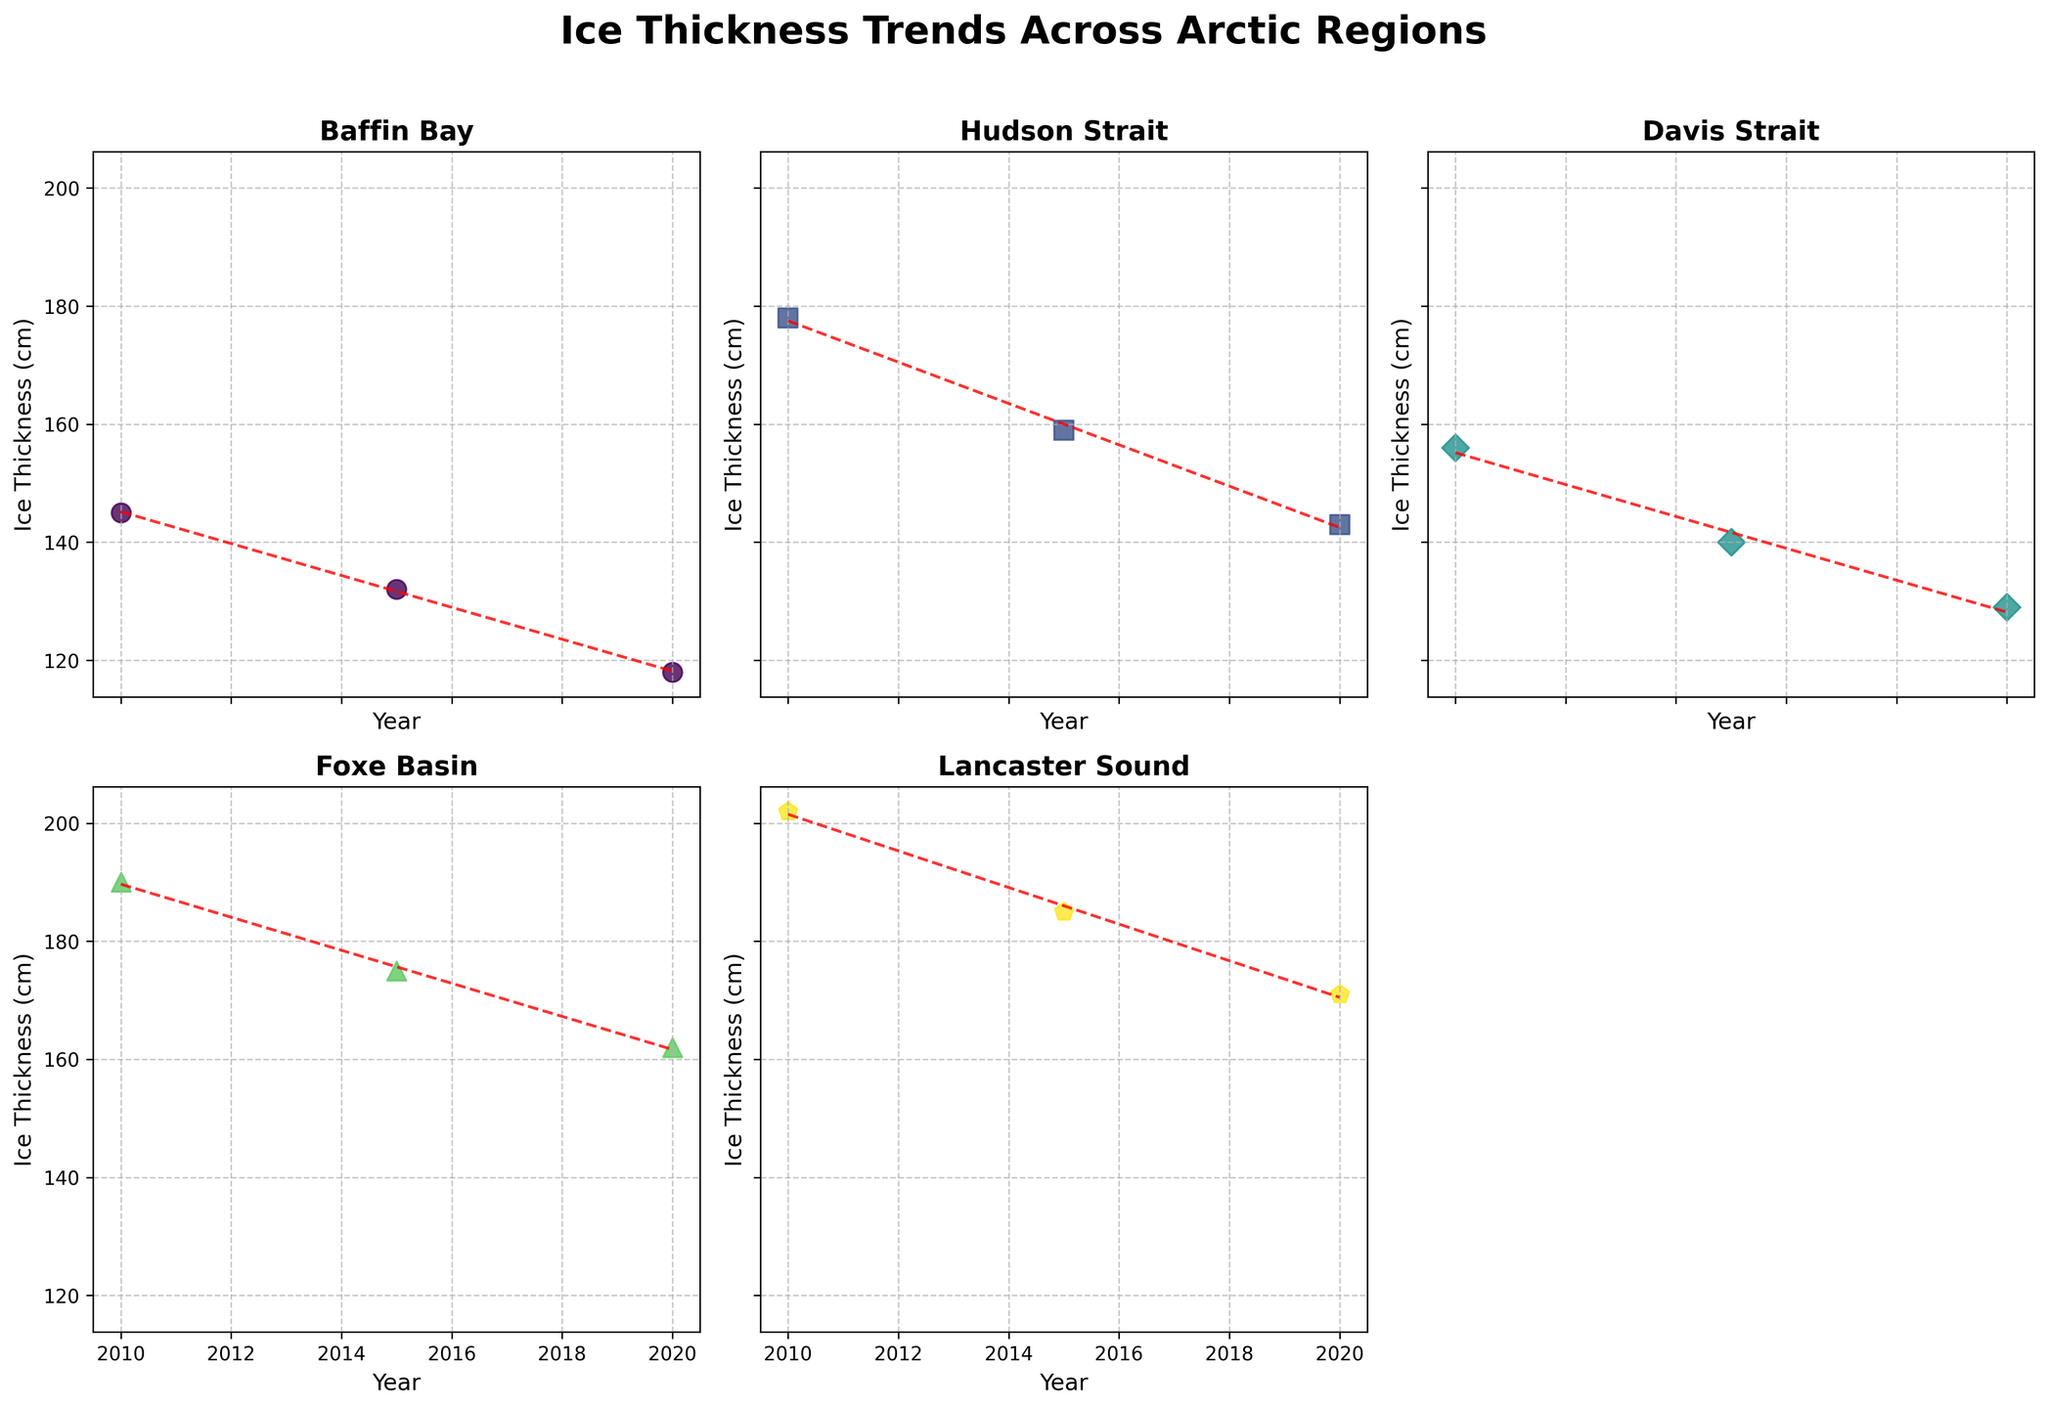What is the general trend for ice thickness in Baffin Bay over the years? From the scatter plot, you can see a downward trend in the ice thickness measurements from 2010 to 2020, indicating that the ice is getting thinner over time.
Answer: The ice thickness in Baffin Bay is decreasing over the years Which region has the highest ice thickness in 2020? By observing the plot, you can compare the data points for 2020 across all regions. Lancaster Sound has the highest ice thickness in 2020 at 171 cm.
Answer: Lancaster Sound Which region shows the steepest decline in ice thickness over the years? By comparing the slopes of the trend lines in each subplot, you can determine which one has the most negative slope. The steepest decline appears in Hudson Strait.
Answer: Hudson Strait How many data points are there for each region? Each subplot shows three data points for the years 2010, 2015, and 2020. Therefore, every region has three data points.
Answer: 3 Which two regions have the closest ice thickness measurements in 2015? Checking the values for 2015 across all regions, Davis Strait and Baffin Bay have measurements close to each other: 140 cm and 132 cm respectively.
Answer: Davis Strait and Baffin Bay Is there a region where the ice thickness remains fairly consistent over the years? By examining the slopes of the trend lines, you can find that none of the regions have a flat trend line, indicating all regions show some decline. However, Davis Strait has a less steep decline compared to others.
Answer: No region remains consistent, but Davis Strait is the least steep What's the average ice thickness in Foxe Basin over the given years? The data points for Foxe Basin from 2010, 2015, and 2020 are 190 cm, 175 cm, and 162 cm. The average can be calculated as (190 + 175 + 162) / 3.
Answer: 175.67 cm Compare the ice thickness of Lancaster Sound in 2010 and 2020. By how much did it change? In the subplot for Lancaster Sound, the data points are 202 cm for 2010 and 171 cm for 2020. The change is calculated as 202 - 171.
Answer: 31 cm What do all the trend lines indicate about the future ice thickness if this pattern continues? By observing the downward slopes of the trend lines in all regions, it indicates that if the current pattern continues, the ice thickness will continue to decrease in the future.
Answer: Future ice thickness is expected to decrease What is represented by the different markers in each subplot? Each subplot has different markers such as circles, squares, diamonds, etc., representing different regions.
Answer: Different regions 